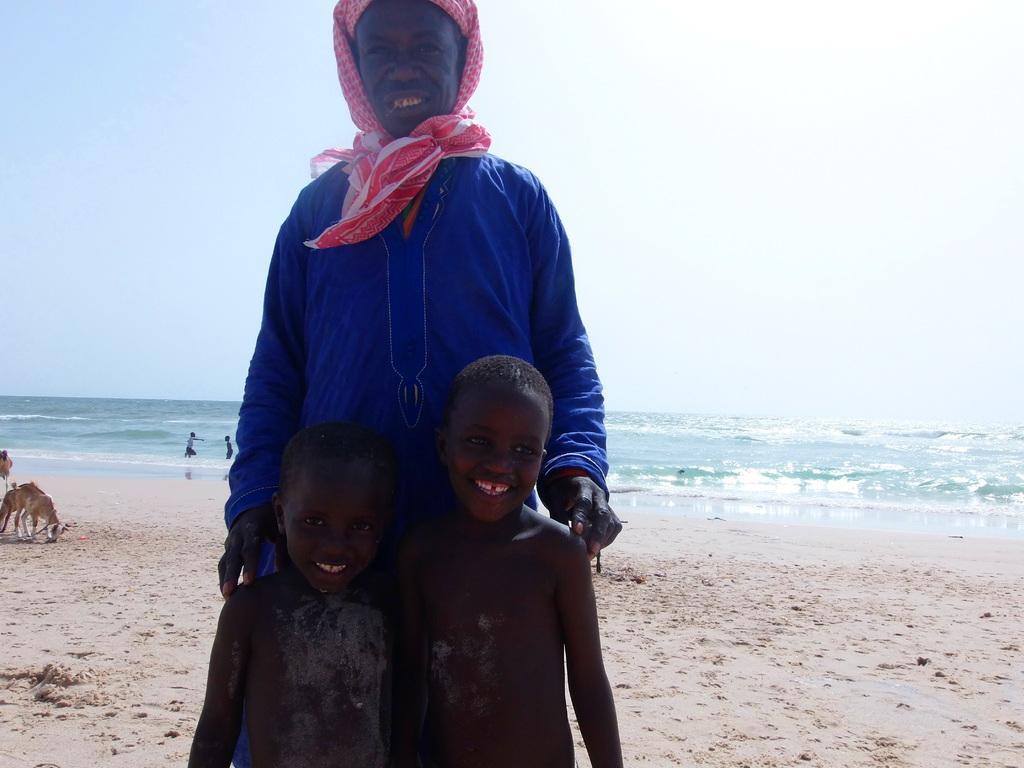Could you give a brief overview of what you see in this image? This is a beach. Here I can see a person and two children standing, smiling and giving pose for the picture. The person is wearing blue color dress and I can see a neckwear. On the the left side there is an animal and two people are playing in the water. On the top of the image I can see the sky. 